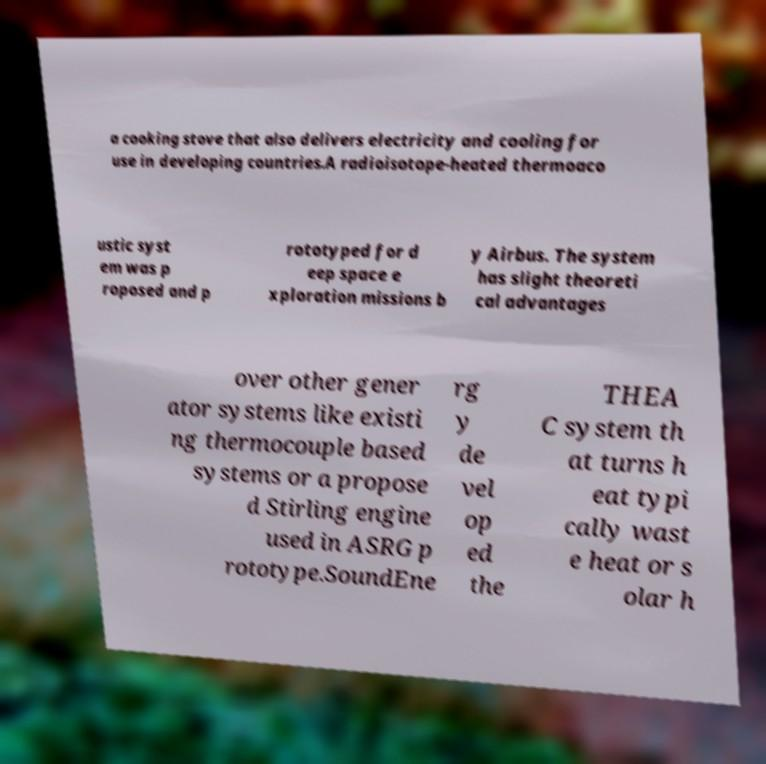Can you read and provide the text displayed in the image?This photo seems to have some interesting text. Can you extract and type it out for me? a cooking stove that also delivers electricity and cooling for use in developing countries.A radioisotope-heated thermoaco ustic syst em was p roposed and p rototyped for d eep space e xploration missions b y Airbus. The system has slight theoreti cal advantages over other gener ator systems like existi ng thermocouple based systems or a propose d Stirling engine used in ASRG p rototype.SoundEne rg y de vel op ed the THEA C system th at turns h eat typi cally wast e heat or s olar h 